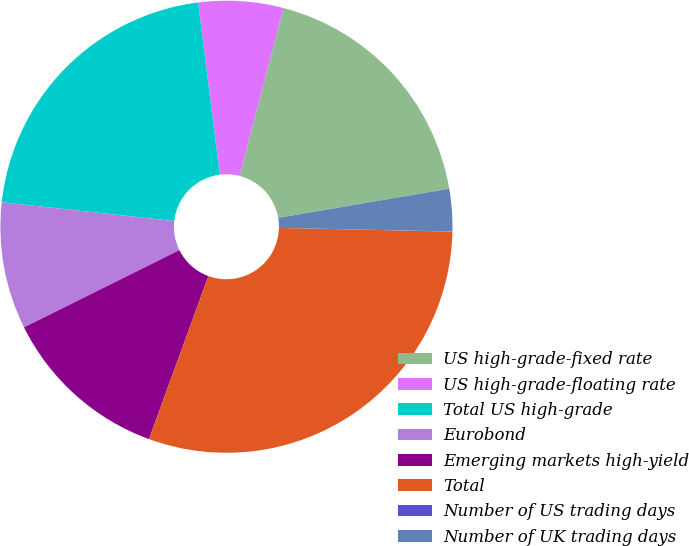<chart> <loc_0><loc_0><loc_500><loc_500><pie_chart><fcel>US high-grade-fixed rate<fcel>US high-grade-floating rate<fcel>Total US high-grade<fcel>Eurobond<fcel>Emerging markets high-yield<fcel>Total<fcel>Number of US trading days<fcel>Number of UK trading days<nl><fcel>18.25%<fcel>6.05%<fcel>21.27%<fcel>9.07%<fcel>12.09%<fcel>30.21%<fcel>0.01%<fcel>3.03%<nl></chart> 